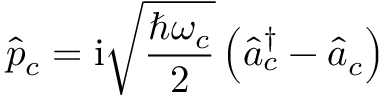<formula> <loc_0><loc_0><loc_500><loc_500>\hat { p } _ { c } = i \sqrt { \frac { \hbar { \omega } _ { c } } { 2 } } \left ( \hat { a } _ { c } ^ { \dagger } - \hat { a } _ { c } \right )</formula> 